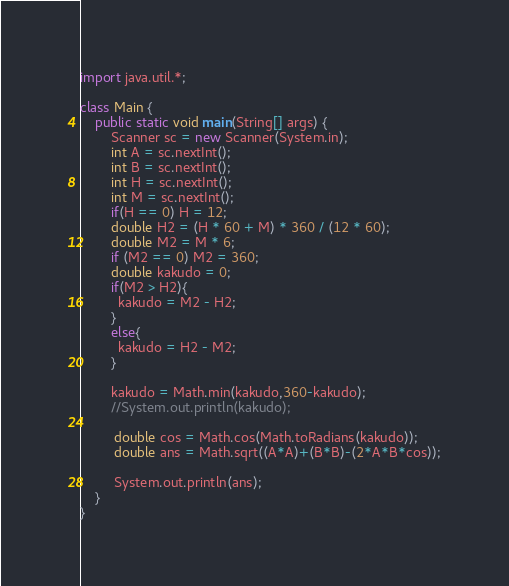Convert code to text. <code><loc_0><loc_0><loc_500><loc_500><_Java_>import java.util.*;

class Main {
    public static void main(String[] args) {
        Scanner sc = new Scanner(System.in);
      	int A = sc.nextInt();
      	int B = sc.nextInt();
      	int H = sc.nextInt();
      	int M = sc.nextInt();
      	if(H == 0) H = 12;
		double H2 = (H * 60 + M) * 360 / (12 * 60);
        double M2 = M * 6;
      	if (M2 == 0) M2 = 360;
      	double kakudo = 0;
      	if(M2 > H2){
	      kakudo = M2 - H2;
        }
      	else{
          kakudo = H2 - M2;
    	}
      	
      	kakudo = Math.min(kakudo,360-kakudo);
      	//System.out.println(kakudo);
      	
         double cos = Math.cos(Math.toRadians(kakudo));
      	 double ans = Math.sqrt((A*A)+(B*B)-(2*A*B*cos));

         System.out.println(ans);
    }
}</code> 